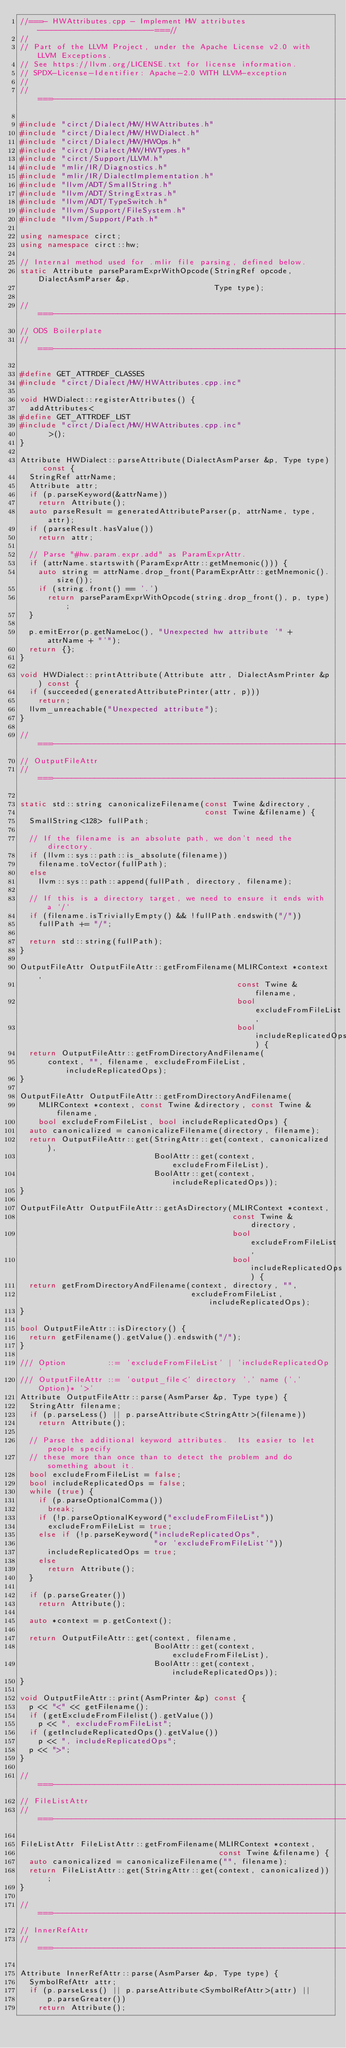Convert code to text. <code><loc_0><loc_0><loc_500><loc_500><_C++_>//===- HWAttributes.cpp - Implement HW attributes -------------------------===//
//
// Part of the LLVM Project, under the Apache License v2.0 with LLVM Exceptions.
// See https://llvm.org/LICENSE.txt for license information.
// SPDX-License-Identifier: Apache-2.0 WITH LLVM-exception
//
//===----------------------------------------------------------------------===//

#include "circt/Dialect/HW/HWAttributes.h"
#include "circt/Dialect/HW/HWDialect.h"
#include "circt/Dialect/HW/HWOps.h"
#include "circt/Dialect/HW/HWTypes.h"
#include "circt/Support/LLVM.h"
#include "mlir/IR/Diagnostics.h"
#include "mlir/IR/DialectImplementation.h"
#include "llvm/ADT/SmallString.h"
#include "llvm/ADT/StringExtras.h"
#include "llvm/ADT/TypeSwitch.h"
#include "llvm/Support/FileSystem.h"
#include "llvm/Support/Path.h"

using namespace circt;
using namespace circt::hw;

// Internal method used for .mlir file parsing, defined below.
static Attribute parseParamExprWithOpcode(StringRef opcode, DialectAsmParser &p,
                                          Type type);

//===----------------------------------------------------------------------===//
// ODS Boilerplate
//===----------------------------------------------------------------------===//

#define GET_ATTRDEF_CLASSES
#include "circt/Dialect/HW/HWAttributes.cpp.inc"

void HWDialect::registerAttributes() {
  addAttributes<
#define GET_ATTRDEF_LIST
#include "circt/Dialect/HW/HWAttributes.cpp.inc"
      >();
}

Attribute HWDialect::parseAttribute(DialectAsmParser &p, Type type) const {
  StringRef attrName;
  Attribute attr;
  if (p.parseKeyword(&attrName))
    return Attribute();
  auto parseResult = generatedAttributeParser(p, attrName, type, attr);
  if (parseResult.hasValue())
    return attr;

  // Parse "#hw.param.expr.add" as ParamExprAttr.
  if (attrName.startswith(ParamExprAttr::getMnemonic())) {
    auto string = attrName.drop_front(ParamExprAttr::getMnemonic().size());
    if (string.front() == '.')
      return parseParamExprWithOpcode(string.drop_front(), p, type);
  }

  p.emitError(p.getNameLoc(), "Unexpected hw attribute '" + attrName + "'");
  return {};
}

void HWDialect::printAttribute(Attribute attr, DialectAsmPrinter &p) const {
  if (succeeded(generatedAttributePrinter(attr, p)))
    return;
  llvm_unreachable("Unexpected attribute");
}

//===----------------------------------------------------------------------===//
// OutputFileAttr
//===----------------------------------------------------------------------===//

static std::string canonicalizeFilename(const Twine &directory,
                                        const Twine &filename) {
  SmallString<128> fullPath;

  // If the filename is an absolute path, we don't need the directory.
  if (llvm::sys::path::is_absolute(filename))
    filename.toVector(fullPath);
  else
    llvm::sys::path::append(fullPath, directory, filename);

  // If this is a directory target, we need to ensure it ends with a `/`
  if (filename.isTriviallyEmpty() && !fullPath.endswith("/"))
    fullPath += "/";

  return std::string(fullPath);
}

OutputFileAttr OutputFileAttr::getFromFilename(MLIRContext *context,
                                               const Twine &filename,
                                               bool excludeFromFileList,
                                               bool includeReplicatedOps) {
  return OutputFileAttr::getFromDirectoryAndFilename(
      context, "", filename, excludeFromFileList, includeReplicatedOps);
}

OutputFileAttr OutputFileAttr::getFromDirectoryAndFilename(
    MLIRContext *context, const Twine &directory, const Twine &filename,
    bool excludeFromFileList, bool includeReplicatedOps) {
  auto canonicalized = canonicalizeFilename(directory, filename);
  return OutputFileAttr::get(StringAttr::get(context, canonicalized),
                             BoolAttr::get(context, excludeFromFileList),
                             BoolAttr::get(context, includeReplicatedOps));
}

OutputFileAttr OutputFileAttr::getAsDirectory(MLIRContext *context,
                                              const Twine &directory,
                                              bool excludeFromFileList,
                                              bool includeReplicatedOps) {
  return getFromDirectoryAndFilename(context, directory, "",
                                     excludeFromFileList, includeReplicatedOps);
}

bool OutputFileAttr::isDirectory() {
  return getFilename().getValue().endswith("/");
}

/// Option         ::= 'excludeFromFileList' | 'includeReplicatedOp'
/// OutputFileAttr ::= 'output_file<' directory ',' name (',' Option)* '>'
Attribute OutputFileAttr::parse(AsmParser &p, Type type) {
  StringAttr filename;
  if (p.parseLess() || p.parseAttribute<StringAttr>(filename))
    return Attribute();

  // Parse the additional keyword attributes.  Its easier to let people specify
  // these more than once than to detect the problem and do something about it.
  bool excludeFromFileList = false;
  bool includeReplicatedOps = false;
  while (true) {
    if (p.parseOptionalComma())
      break;
    if (!p.parseOptionalKeyword("excludeFromFileList"))
      excludeFromFileList = true;
    else if (!p.parseKeyword("includeReplicatedOps",
                             "or 'excludeFromFileList'"))
      includeReplicatedOps = true;
    else
      return Attribute();
  }

  if (p.parseGreater())
    return Attribute();

  auto *context = p.getContext();

  return OutputFileAttr::get(context, filename,
                             BoolAttr::get(context, excludeFromFileList),
                             BoolAttr::get(context, includeReplicatedOps));
}

void OutputFileAttr::print(AsmPrinter &p) const {
  p << "<" << getFilename();
  if (getExcludeFromFilelist().getValue())
    p << ", excludeFromFileList";
  if (getIncludeReplicatedOps().getValue())
    p << ", includeReplicatedOps";
  p << ">";
}

//===----------------------------------------------------------------------===//
// FileListAttr
//===----------------------------------------------------------------------===//

FileListAttr FileListAttr::getFromFilename(MLIRContext *context,
                                           const Twine &filename) {
  auto canonicalized = canonicalizeFilename("", filename);
  return FileListAttr::get(StringAttr::get(context, canonicalized));
}

//===----------------------------------------------------------------------===//
// InnerRefAttr
//===----------------------------------------------------------------------===//

Attribute InnerRefAttr::parse(AsmParser &p, Type type) {
  SymbolRefAttr attr;
  if (p.parseLess() || p.parseAttribute<SymbolRefAttr>(attr) ||
      p.parseGreater())
    return Attribute();</code> 